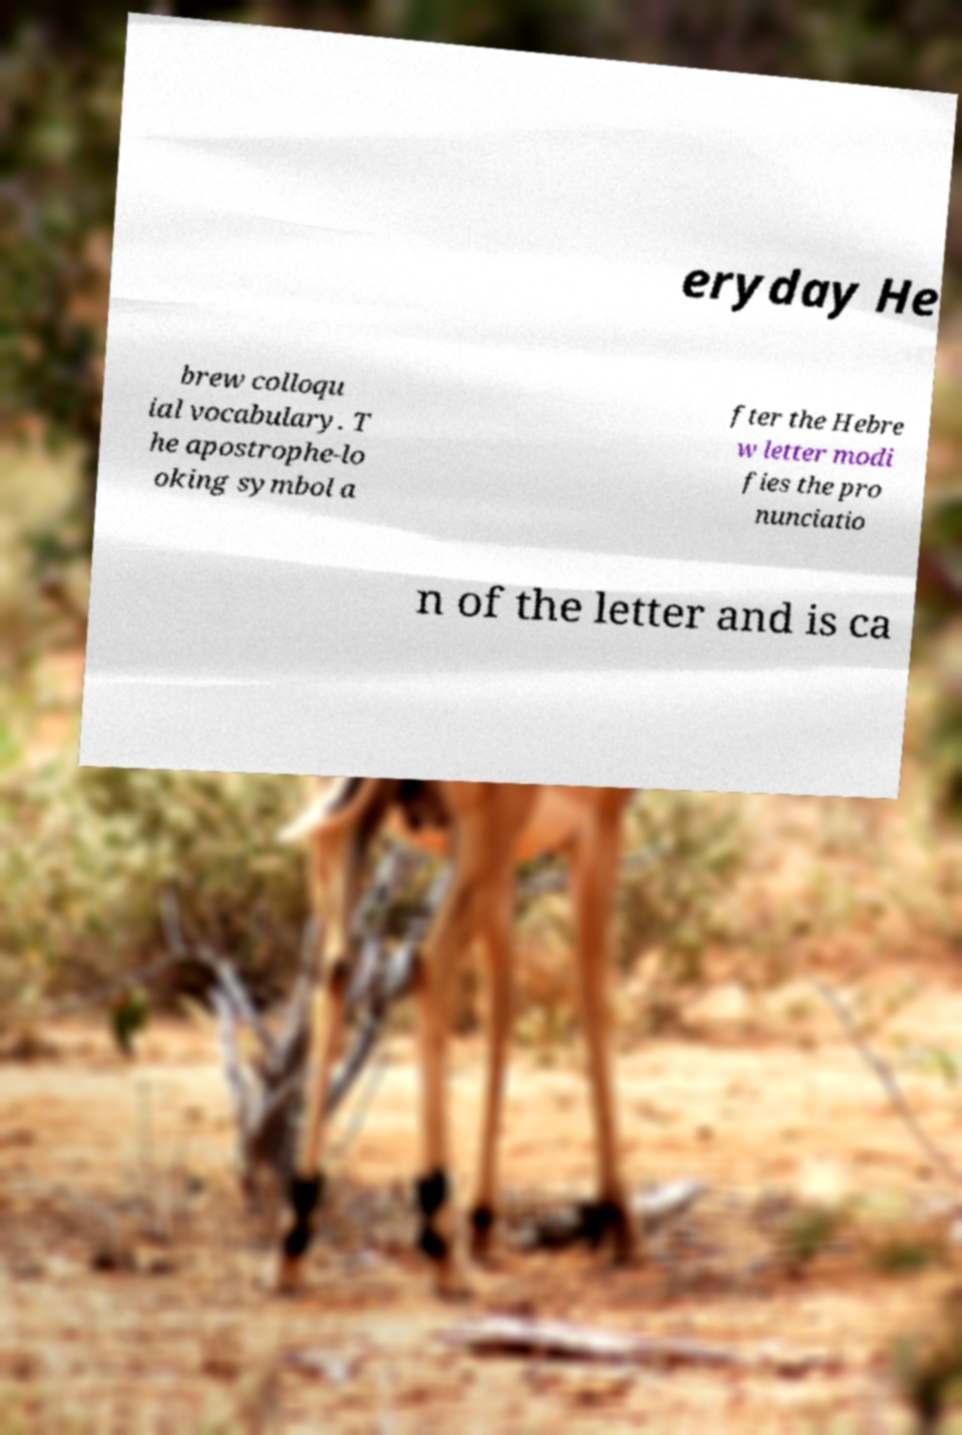Please read and relay the text visible in this image. What does it say? eryday He brew colloqu ial vocabulary. T he apostrophe-lo oking symbol a fter the Hebre w letter modi fies the pro nunciatio n of the letter and is ca 